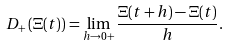<formula> <loc_0><loc_0><loc_500><loc_500>D _ { + } \left ( \Xi ( t ) \right ) = \lim _ { h \to 0 + } \frac { \Xi ( t + h ) - \Xi ( t ) } { h } .</formula> 